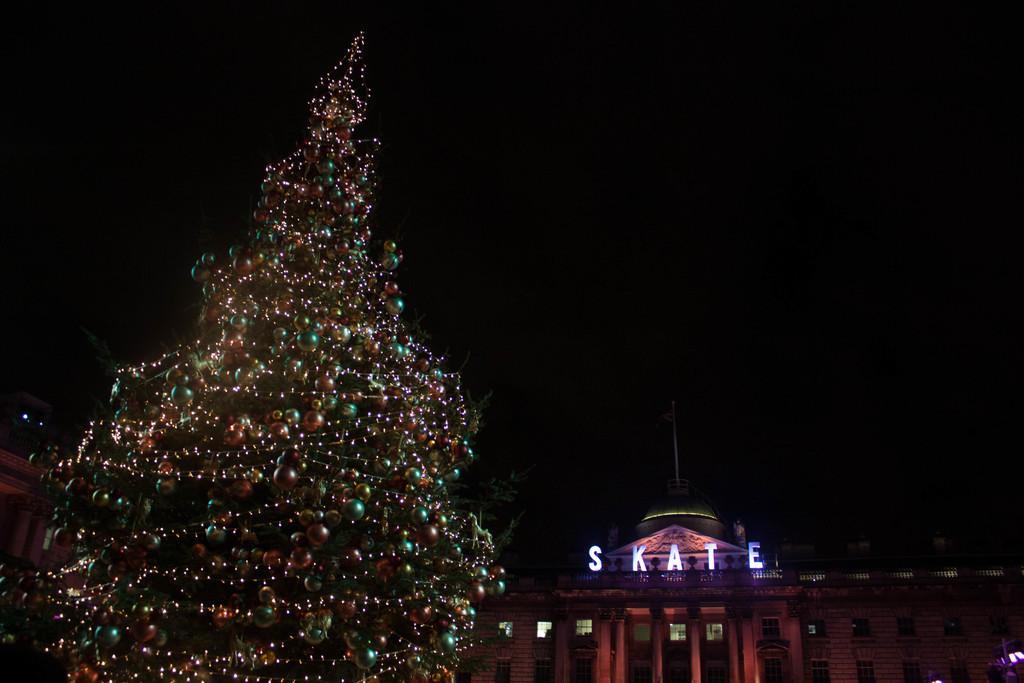Please provide a concise description of this image. In this image we can see Christmas tree which is decorated with lights and balls. And we can see one building beside the Christmas trees on which some text is written. And we can see many windows. 